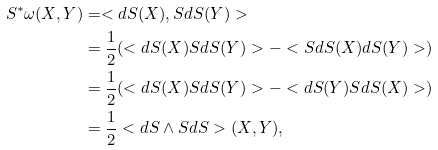<formula> <loc_0><loc_0><loc_500><loc_500>S ^ { * } \omega ( X , Y ) & = < d S ( X ) , S d S ( Y ) > \\ & = \frac { 1 } { 2 } ( < d S ( X ) S d S ( Y ) > - < S d S ( X ) d S ( Y ) > ) \\ & = \frac { 1 } { 2 } ( < d S ( X ) S d S ( Y ) > - < d S ( Y ) S d S ( X ) > ) \\ & = \frac { 1 } { 2 } < d S \wedge S d S > ( X , Y ) ,</formula> 